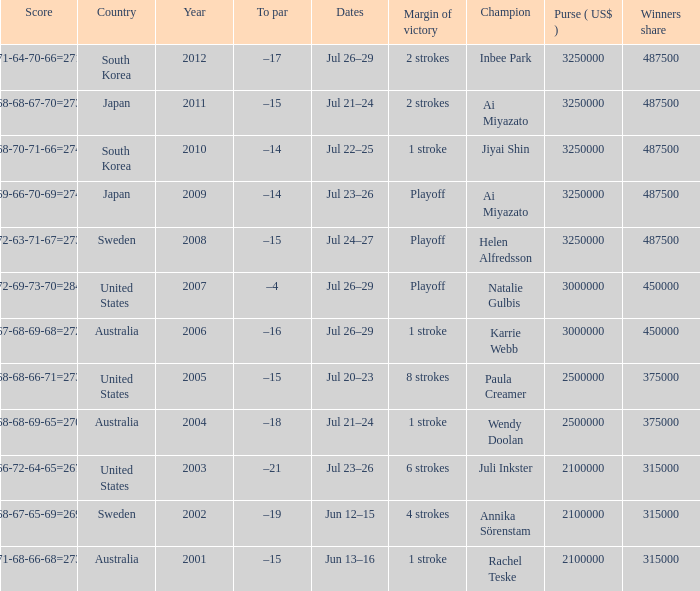What is the lowest year listed? 2001.0. 